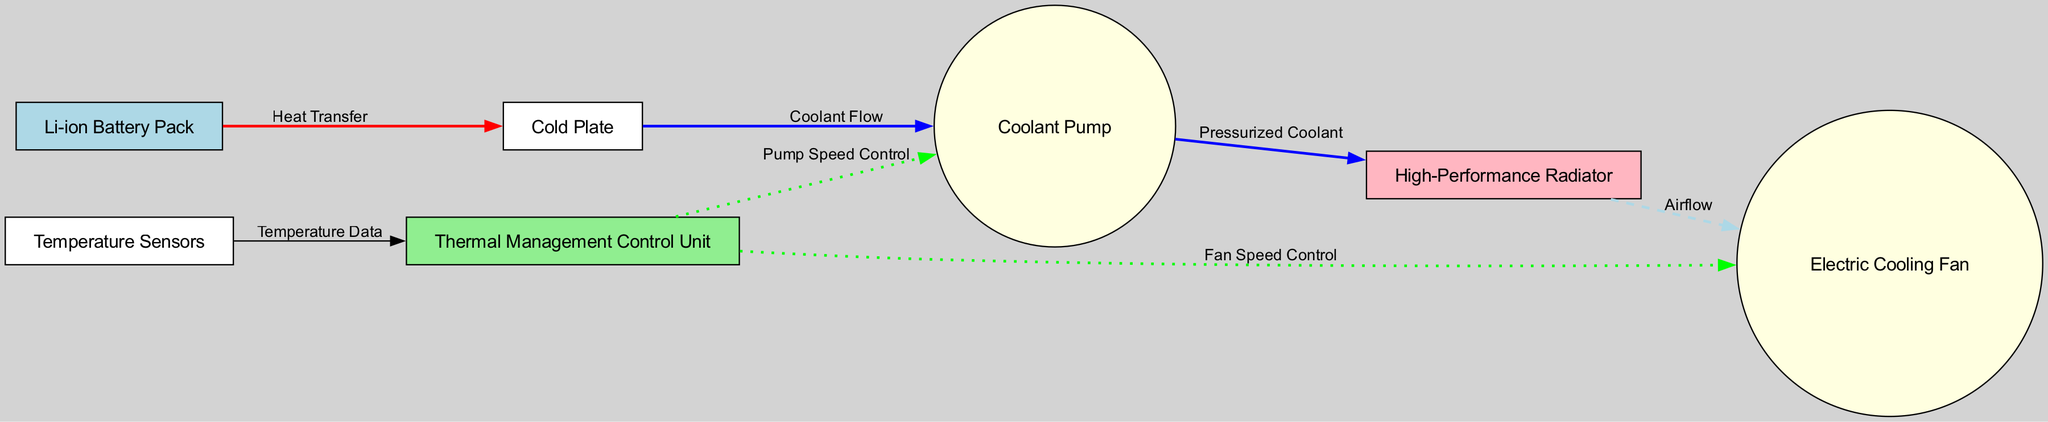What is the first component in the thermal management flow? The diagram shows that the thermal management flow begins at the "Li-ion Battery Pack," which is the first node connected via the "Heat Transfer" edge.
Answer: Li-ion Battery Pack How many edges are present in the diagram? By counting each connection (edge) between the nodes in the diagram, we find there are a total of seven edges.
Answer: 7 What type of control does the Thermal Management Control Unit exercise over the Coolant Pump? The diagram indicates that the "Thermal Management Control Unit" sends "Pump Speed Control" to the "Coolant Pump," representing its control mechanism.
Answer: Pump Speed Control What is the purpose of the Electric Cooling Fan as shown in the diagram? The diagram illustrates that the "Electric Cooling Fan" is involved in "Airflow," suggesting its purpose is to facilitate movement of air for cooling.
Answer: Airflow Which node receives temperature data? The diagram clearly shows that "Temperature Sensors" are sending "Temperature Data" to the "Thermal Management Control Unit," indicating that this unit receives the data.
Answer: Thermal Management Control Unit What flows from the Cold Plate to the Coolant Pump? The connection labeled "Coolant Flow" indicates that coolant transitions from the "Cold Plate" to the "Coolant Pump."
Answer: Coolant Flow What type of node is represented by the High-Performance Radiator? The "High-Performance Radiator" is displayed as a rectangle in the diagram, signifying it is a different type of node compared to others.
Answer: Rectangle Which element controls the speed of the Electric Cooling Fan? According to the diagram, the "Thermal Management Control Unit" controls the speed of the "Electric Cooling Fan" through "Fan Speed Control."
Answer: Fan Speed Control What color represents the nodes associated with pumping solutions (Coolant Pump and Electric Cooling Fan)? The diagram shows that both the "Coolant Pump" and "Electric Cooling Fan" are colored light yellow, indicating they share the same node color.
Answer: Light yellow 